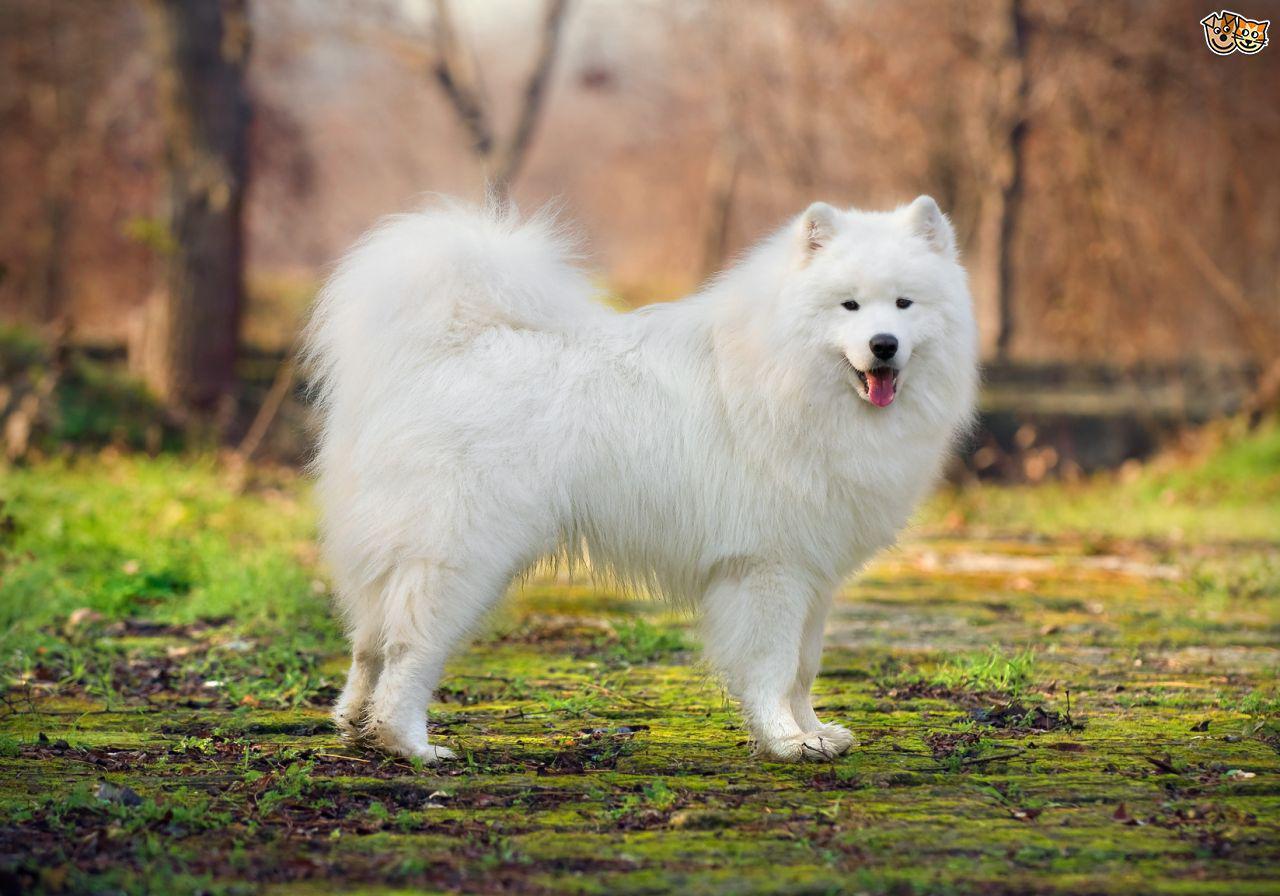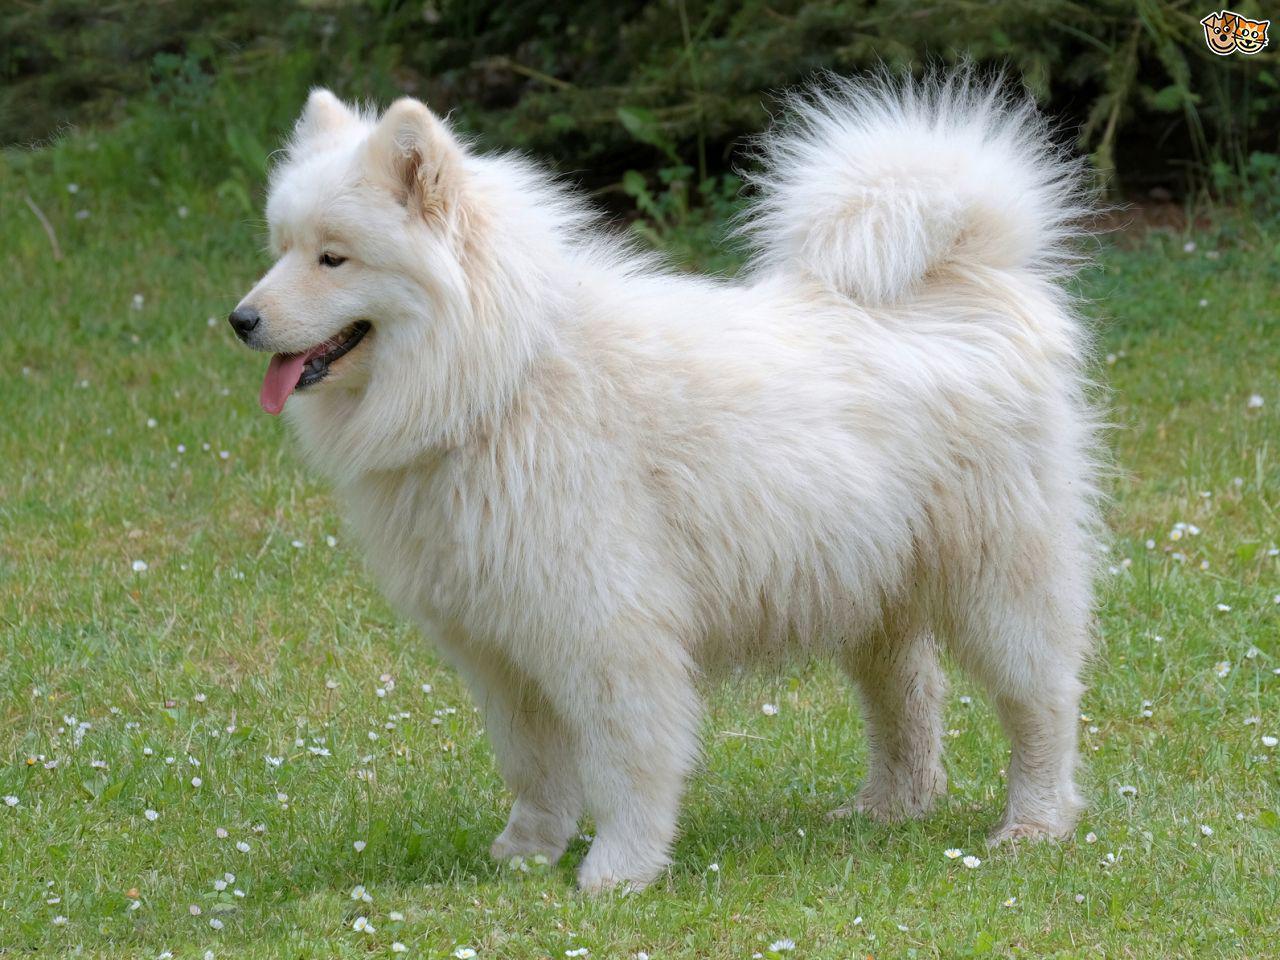The first image is the image on the left, the second image is the image on the right. Assess this claim about the two images: "The dogs appear to be facing each other.". Correct or not? Answer yes or no. Yes. 